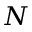<formula> <loc_0><loc_0><loc_500><loc_500>N</formula> 